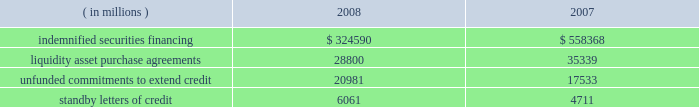The table summarizes the total contractual amount of credit-related , off-balance sheet financial instruments at december 31 .
Amounts reported do not reflect participations to independent third parties. .
Approximately 81% ( 81 % ) of the unfunded commitments to extend credit expire within one year from the date of issue .
Since many of the commitments are expected to expire or renew without being drawn upon , the total commitment amounts do not necessarily represent future cash requirements .
Securities finance : on behalf of our customers , we lend their securities to creditworthy brokers and other institutions .
We generally indemnify our customers for the fair market value of those securities against a failure of the borrower to return such securities .
Collateral funds received in connection with our securities finance services are held by us as agent and are not recorded in our consolidated statement of condition .
We require the borrowers to provide collateral in an amount equal to or in excess of 100% ( 100 % ) of the fair market value of the securities borrowed .
The borrowed securities are revalued daily to determine if additional collateral is necessary .
In this regard , we held , as agent , cash and u.s .
Government securities with an aggregate fair value of $ 333.07 billion and $ 572.93 billion as collateral for indemnified securities on loan at december 31 , 2008 and 2007 , respectively , presented in the table above .
The collateral held by us is invested on behalf of our customers .
In certain cases , the collateral is invested in third-party repurchase agreements , for which we indemnify the customer against loss of the principal invested .
We require the repurchase agreement counterparty to provide collateral in an amount equal to or in excess of 100% ( 100 % ) of the amount of the repurchase agreement .
The indemnified repurchase agreements and the related collateral are not recorded in our consolidated statement of condition .
Of the collateral of $ 333.07 billion at december 31 , 2008 and $ 572.93 billion at december 31 , 2007 referenced above , $ 68.37 billion at december 31 , 2008 and $ 106.13 billion at december 31 , 2007 was invested in indemnified repurchase agreements .
We held , as agent , cash and securities with an aggregate fair value of $ 71.87 billion and $ 111.02 billion as collateral for indemnified investments in repurchase agreements at december 31 , 2008 and december 31 , 2007 , respectively .
Asset-backed commercial paper program : in the normal course of our business , we provide liquidity and credit enhancement to an asset-backed commercial paper program sponsored and administered by us , described in note 12 .
The commercial paper issuances and commitments of the commercial paper conduits to provide funding are supported by liquidity asset purchase agreements and back-up liquidity lines of credit , the majority of which are provided by us .
In addition , we provide direct credit support to the conduits in the form of standby letters of credit .
Our commitments under liquidity asset purchase agreements and back-up lines of credit totaled $ 23.59 billion at december 31 , 2008 , and are included in the preceding table .
Our commitments under standby letters of credit totaled $ 1.00 billion at december 31 , 2008 , and are also included in the preceding table .
Legal proceedings : several customers have filed litigation claims against us , some of which are putative class actions purportedly on behalf of customers invested in certain of state street global advisors 2019 , or ssga 2019s , active fixed-income strategies .
These claims related to investment losses in one or more of ssga 2019s strategies that included sub-prime investments .
In 2007 , we established a reserve of approximately $ 625 million to address legal exposure associated with the under-performance of certain active fixed-income strategies managed by ssga and customer concerns as to whether the execution of these strategies was consistent with the customers 2019 investment intent .
These strategies were adversely impacted by exposure to , and the lack of liquidity in .
What portion of the 2007 collateral was invested in indemnified repurchase agreements in 2007? 
Computations: (106.13 / 572.93)
Answer: 0.18524. 